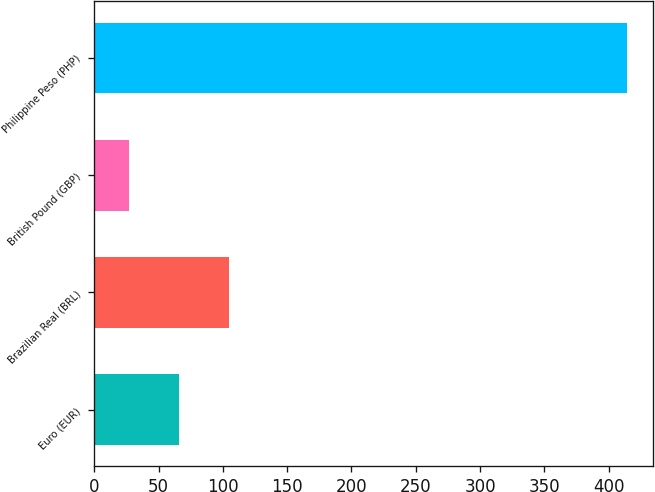Convert chart to OTSL. <chart><loc_0><loc_0><loc_500><loc_500><bar_chart><fcel>Euro (EUR)<fcel>Brazilian Real (BRL)<fcel>British Pound (GBP)<fcel>Philippine Peso (PHP)<nl><fcel>65.7<fcel>104.4<fcel>27<fcel>414<nl></chart> 